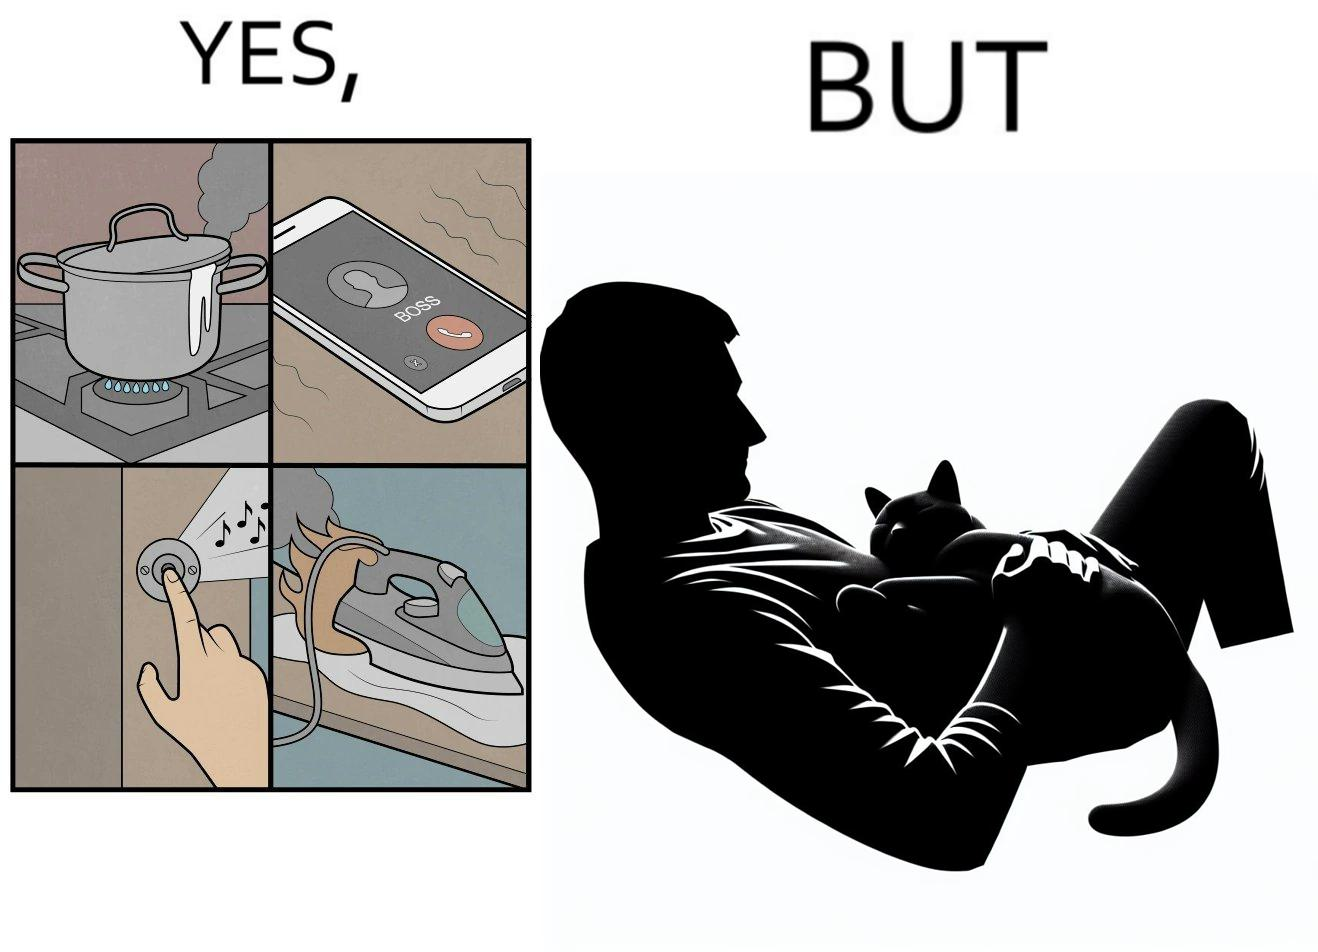Does this image contain satire or humor? Yes, this image is satirical. 